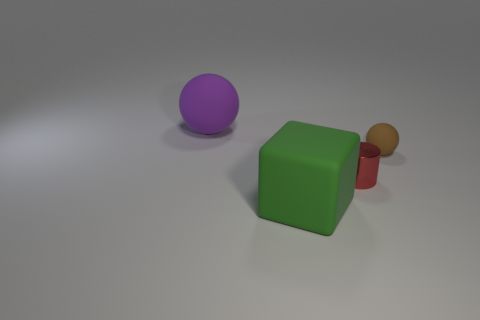Add 2 large purple matte things. How many objects exist? 6 Subtract all blocks. How many objects are left? 3 Subtract 0 blue cubes. How many objects are left? 4 Subtract all gray objects. Subtract all small red cylinders. How many objects are left? 3 Add 1 purple rubber objects. How many purple rubber objects are left? 2 Add 4 tiny cylinders. How many tiny cylinders exist? 5 